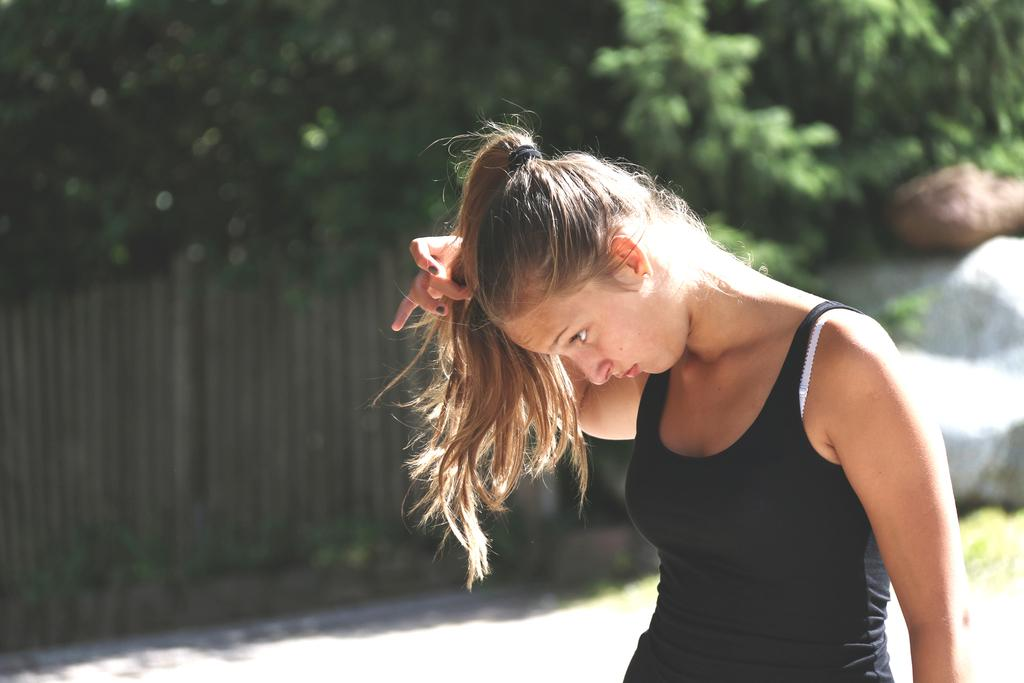Who is present in the image? There is a woman in the image. What is the woman doing in the image? The woman is standing. What is the woman wearing in the image? The woman is wearing a black dress. What can be seen in the background of the image? There is a wooden fence and trees in the background of the image. What is the power of the woman's arm in the image? There is no mention of power or the woman's arm in the image. 